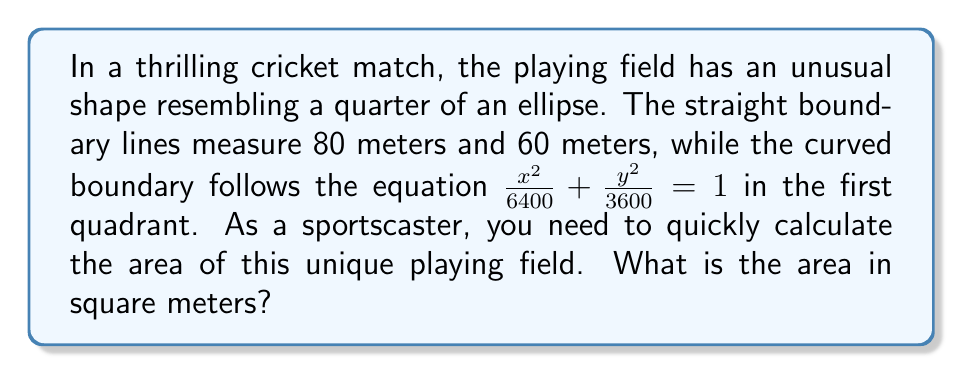Teach me how to tackle this problem. Let's approach this step-by-step using concepts from field theory:

1) The field is shaped like a quarter of an ellipse. The general equation of an ellipse is:

   $$\frac{x^2}{a^2} + \frac{y^2}{b^2} = 1$$

2) From the given equation, we can identify that $a^2 = 6400$ and $b^2 = 3600$. Therefore:
   
   $a = 80$ meters and $b = 60$ meters

3) The area of a full ellipse is given by the formula:

   $$A_{full} = \pi ab$$

4) However, we only need a quarter of this area. So our formula becomes:

   $$A_{quarter} = \frac{1}{4} \pi ab$$

5) Substituting our values:

   $$A_{quarter} = \frac{1}{4} \pi (80)(60) = 1200\pi$$

6) To get the final answer in square meters:

   $$A_{quarter} = 1200\pi \approx 3769.91 \text{ m}^2$$

Therefore, the area of the irregular-shaped cricket field is approximately 3769.91 square meters.
Answer: $3769.91 \text{ m}^2$ 